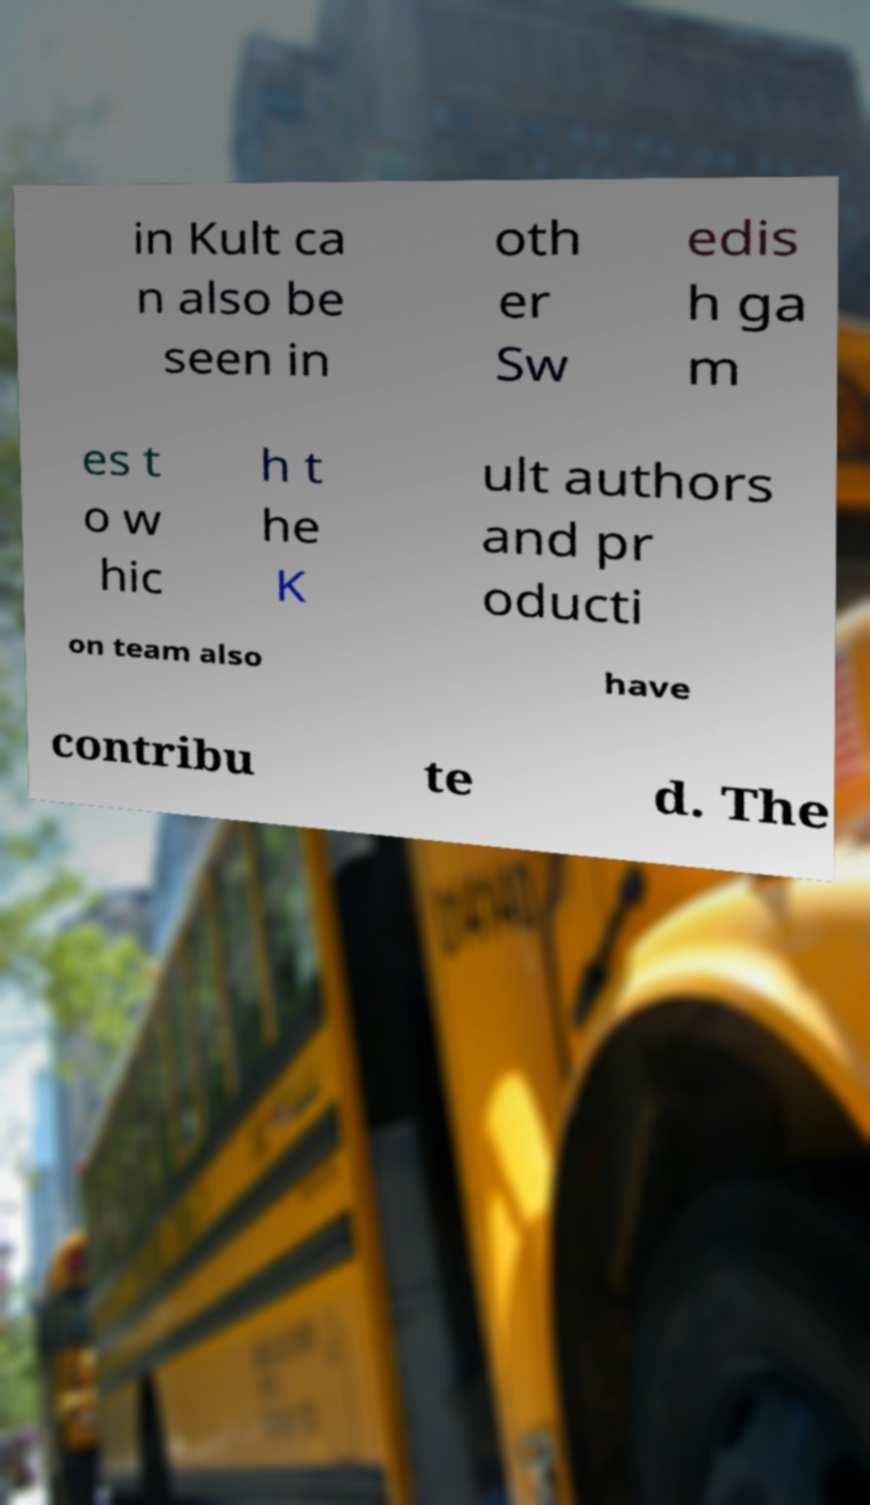What messages or text are displayed in this image? I need them in a readable, typed format. in Kult ca n also be seen in oth er Sw edis h ga m es t o w hic h t he K ult authors and pr oducti on team also have contribu te d. The 